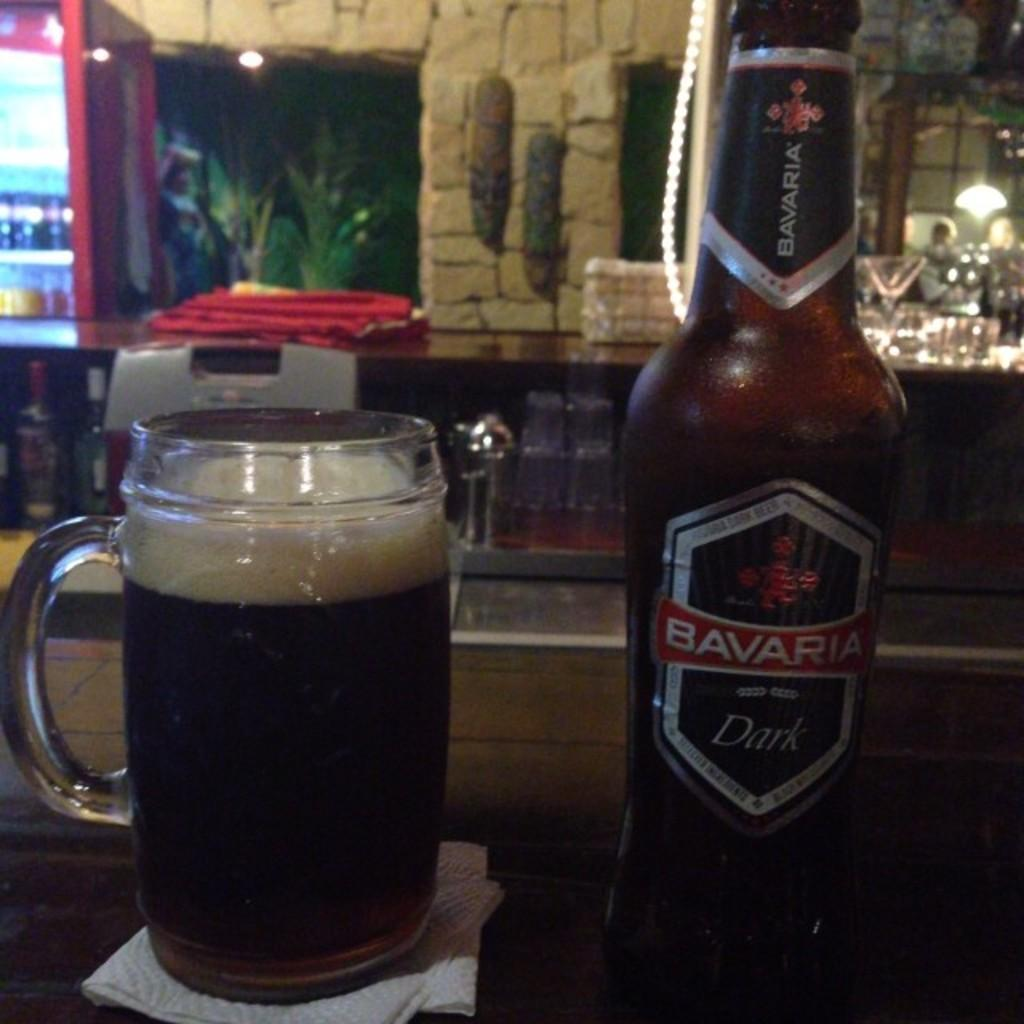Provide a one-sentence caption for the provided image. Cup of beer next to a Bavaria beer bottle. 